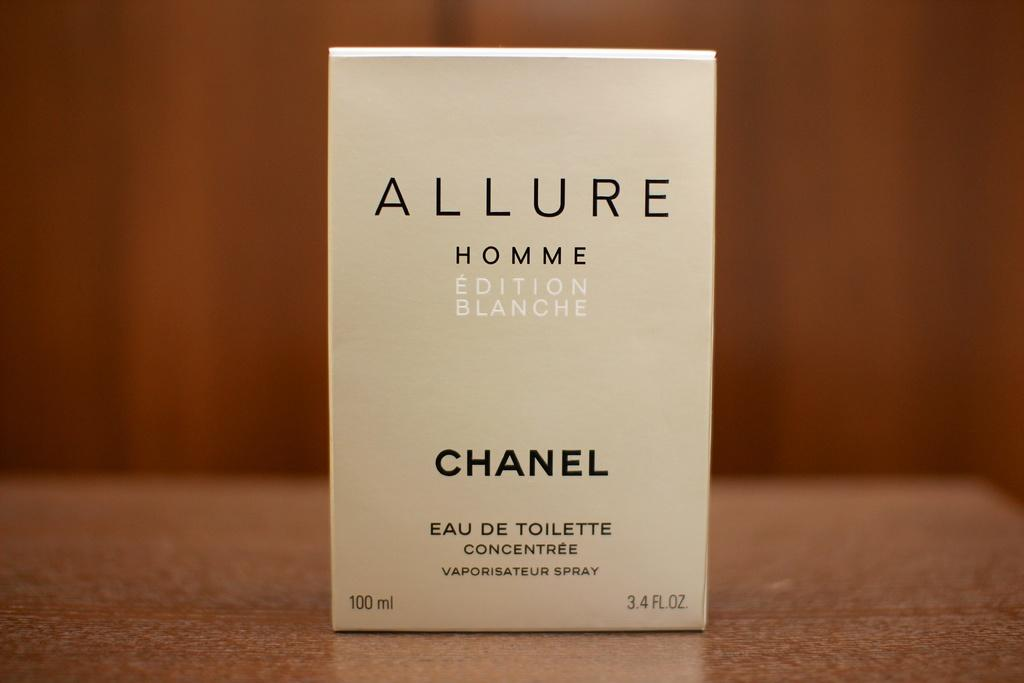<image>
Render a clear and concise summary of the photo. A box of Allure by Chanel sits upright. 